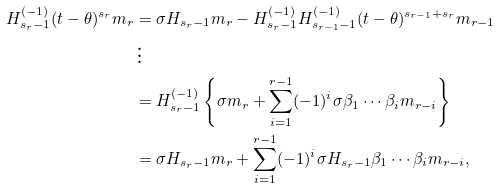<formula> <loc_0><loc_0><loc_500><loc_500>H _ { s _ { r } - 1 } ^ { ( - 1 ) } ( t - \theta ) ^ { s _ { r } } m _ { r } & = \sigma H _ { s _ { r } - 1 } m _ { r } - H _ { s _ { r } - 1 } ^ { ( - 1 ) } H _ { s _ { r - 1 } - 1 } ^ { ( - 1 ) } ( t - \theta ) ^ { s _ { r - 1 } + s _ { r } } m _ { r - 1 } \\ & \, \vdots \\ & = H _ { s _ { r } - 1 } ^ { ( - 1 ) } \left \{ \sigma m _ { r } + \sum _ { i = 1 } ^ { r - 1 } ( - 1 ) ^ { i } \sigma \beta _ { 1 } \cdots \beta _ { i } m _ { r - i } \right \} \\ & = \sigma H _ { s _ { r } - 1 } m _ { r } + \sum _ { i = 1 } ^ { r - 1 } ( - 1 ) ^ { i } \sigma H _ { s _ { r } - 1 } \beta _ { 1 } \cdots \beta _ { i } m _ { r - i } ,</formula> 